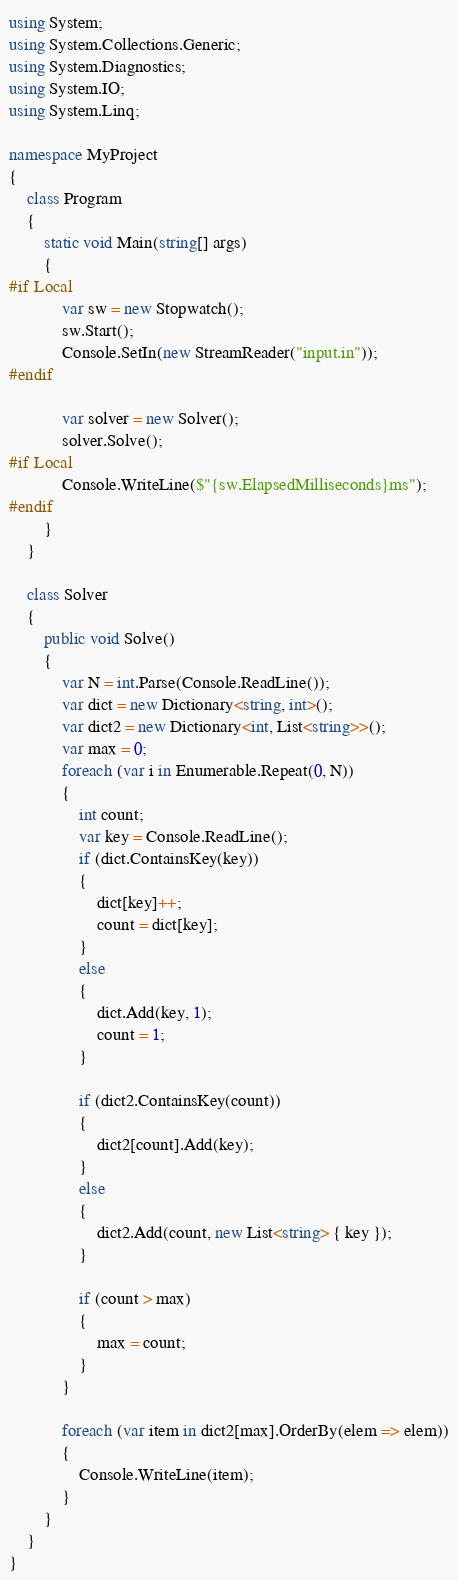Convert code to text. <code><loc_0><loc_0><loc_500><loc_500><_C#_>using System;
using System.Collections.Generic;
using System.Diagnostics;
using System.IO;
using System.Linq;

namespace MyProject
{
    class Program
    {
        static void Main(string[] args)
        {
#if Local
            var sw = new Stopwatch();
            sw.Start();
            Console.SetIn(new StreamReader("input.in"));
#endif

            var solver = new Solver();
            solver.Solve();
#if Local
            Console.WriteLine($"{sw.ElapsedMilliseconds}ms");
#endif
        }
    }

    class Solver
    {
        public void Solve()
        {
            var N = int.Parse(Console.ReadLine());
            var dict = new Dictionary<string, int>();
            var dict2 = new Dictionary<int, List<string>>();
            var max = 0;
            foreach (var i in Enumerable.Repeat(0, N))
            {
                int count;
                var key = Console.ReadLine();
                if (dict.ContainsKey(key))
                {
                    dict[key]++;
                    count = dict[key];
                }
                else
                {
                    dict.Add(key, 1);
                    count = 1;
                }

                if (dict2.ContainsKey(count))
                {
                    dict2[count].Add(key);
                }
                else
                {
                    dict2.Add(count, new List<string> { key });
                }

                if (count > max)
                {
                    max = count;
                }
            }

            foreach (var item in dict2[max].OrderBy(elem => elem))
            {
                Console.WriteLine(item);
            }
        }
    }
}
</code> 